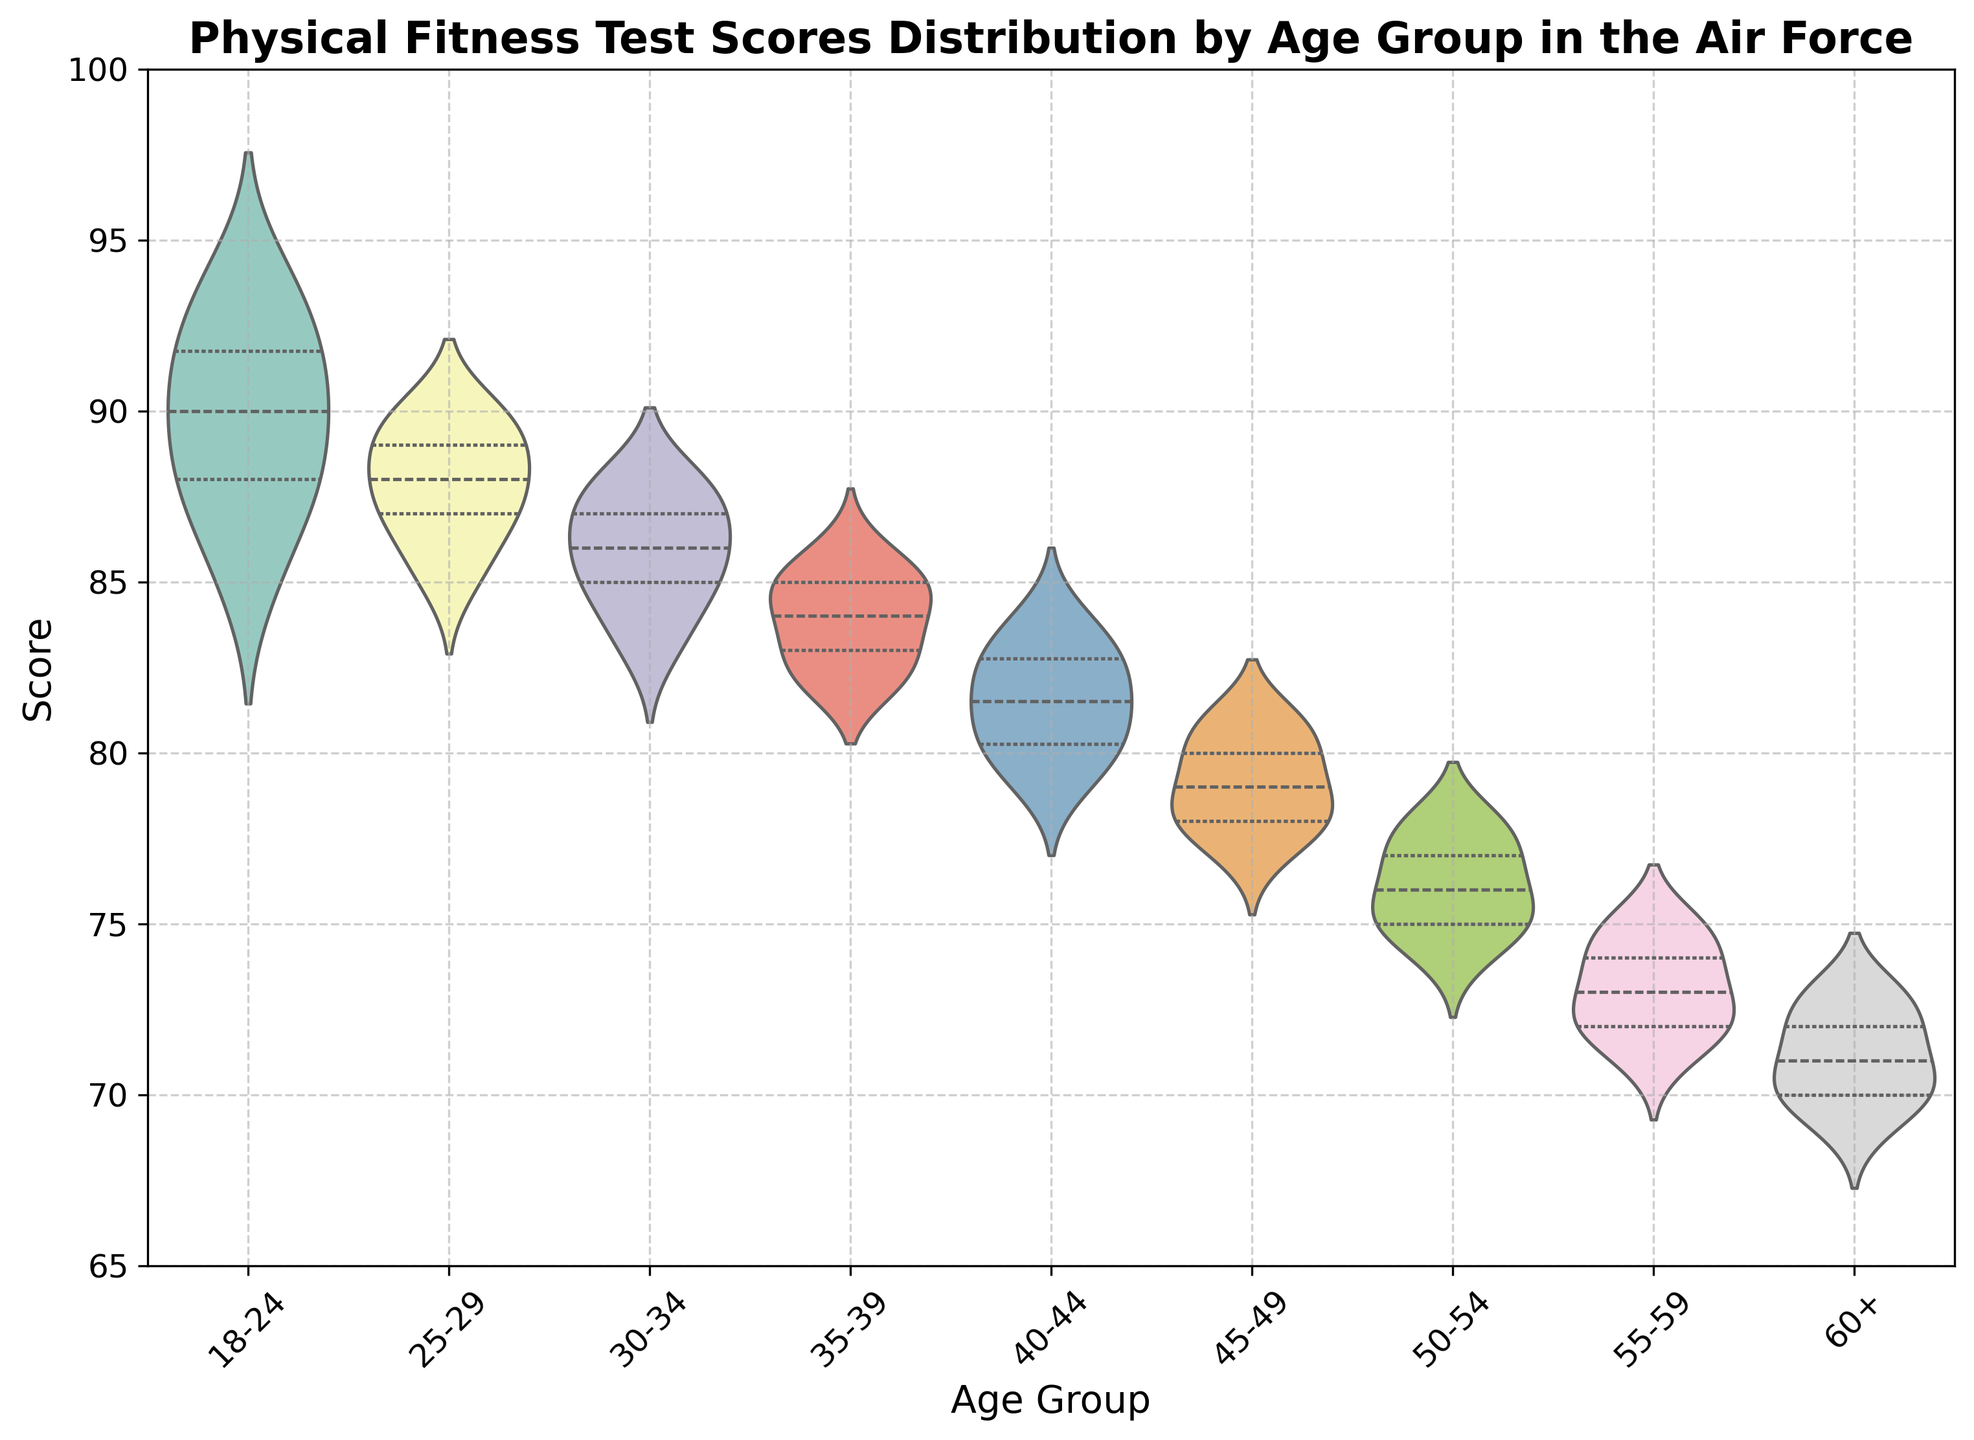What is the median score for the 30-34 age group? The median score is the middle value when the scores are arranged in ascending order. For the 30-34 age group, the sorted scores are [83, 84, 85, 85, 86, 86, 87, 87, 88, 88]. The median of these 10 scores is the average of the 5th and 6th values, which are both 86, so the median is 86.
Answer: 86 Which age group has the highest median score? By inspecting the plot, we look for the highest position of the horizontal line within the violin plot that represents the median. The age group 18-24 has the highest median score.
Answer: 18-24 What is the range of scores in the 60+ age group? The range is determined by subtracting the minimum value from the maximum value. For the 60+ age group, the score ranges from 69 to 73. Therefore, the range is 73 - 69 = 4.
Answer: 4 Which age group shows the smallest spread in test scores? By inspecting the width of the violin plots, the smallest spread, indicating less variability, is seen in the 60+ age group.
Answer: 60+ How do the median scores of the 25-29 and 45-49 age groups compare? By inspecting the horizontal lines representing the medians, we observe that the median score for the 25-29 age group is slightly higher than the median score for the 45-49 age group.
Answer: 25-29 is higher What can you say about the distribution shape of the 35-39 age group? The distribution shape can be observed by looking at the symmetry and spread of the violin plot. The 35-39 age group has a relatively symmetrical distribution with a moderate spread. This suggests that the scores are evenly distributed around the median.
Answer: Symmetrical and moderate spread Which age group has the most interquartile range (IQR)? IQR is represented by the distance between the two inner horizontal lines (at the top and bottom of the box within the violin plot). The age group with the widest IQR, indicating more variability within the middle 50% of scores, is the 18-24 group.
Answer: 18-24 Comparing the 18-24 and 50-54 age groups, which one shows more variability in scores? By comparing the width and spread of the violin plots, the 18-24 age group shows more variability, indicated by a wider spread of scores compared to the narrower spread in the 50-54 group.
Answer: 18-24 How do the upper quartiles (top 25% of scores) of the 40-44 and 55-59 age groups compare? The upper quartile is represented by the position of the horizontal line at the top of the box within the violin plot. The upper quartile for the 40-44 age group is higher than that of the 55-59 age group.
Answer: 40-44 is higher 